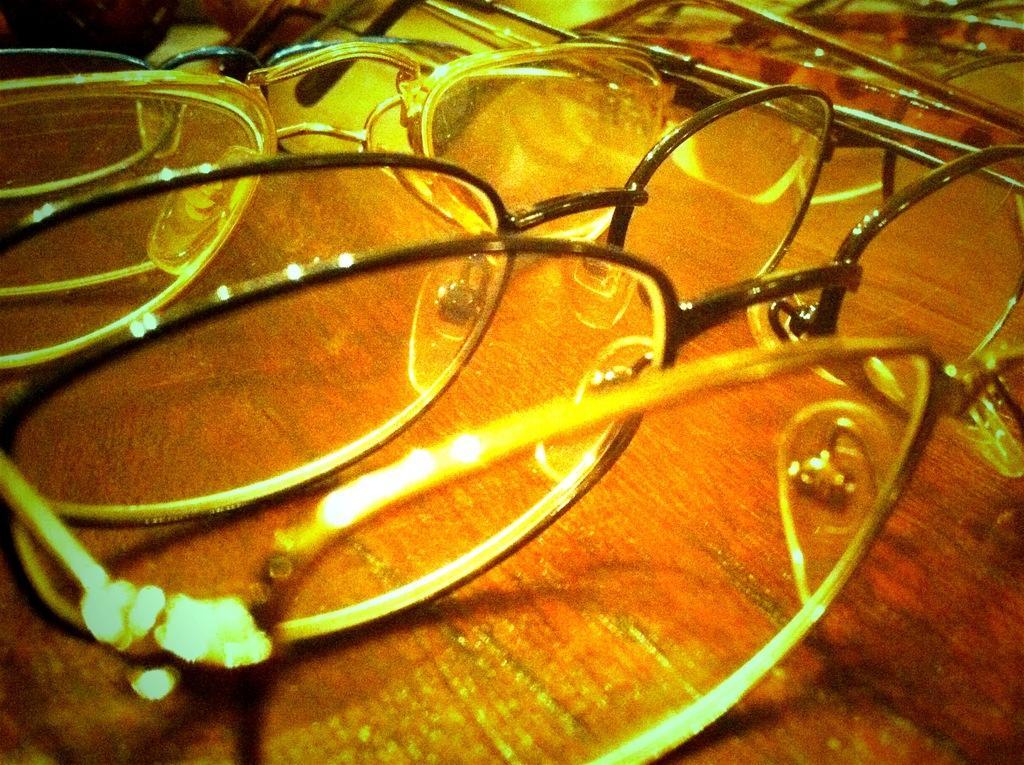Could you give a brief overview of what you see in this image? In this picture there are spectacles. 